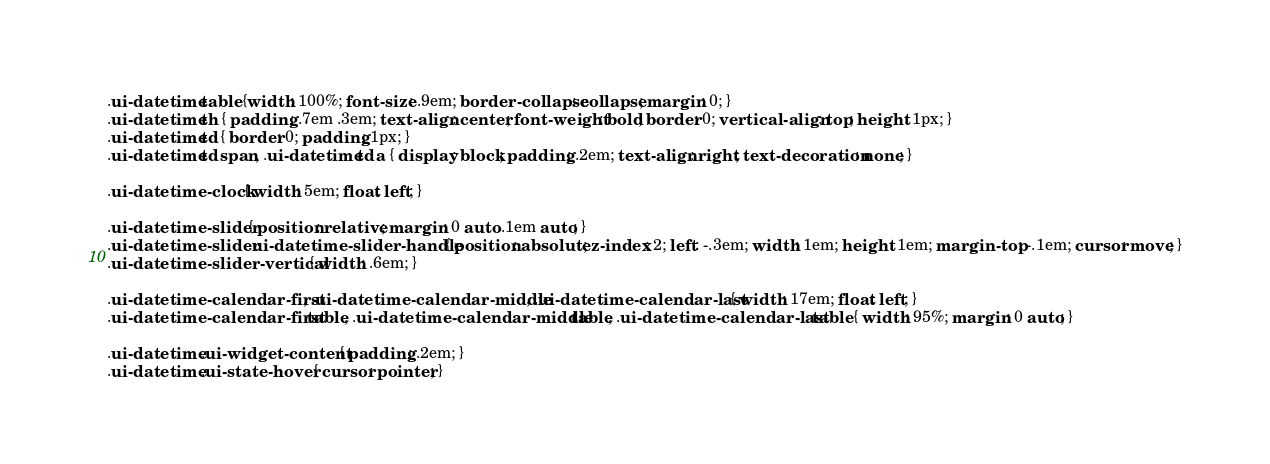Convert code to text. <code><loc_0><loc_0><loc_500><loc_500><_CSS_>
.ui-datetime table {width: 100%; font-size: .9em; border-collapse: collapse; margin: 0; }
.ui-datetime th { padding: .7em .3em; text-align: center; font-weight: bold; border: 0; vertical-align: top; height: 1px; }
.ui-datetime td { border: 0; padding: 1px; }
.ui-datetime td span, .ui-datetime td a { display: block; padding: .2em; text-align: right; text-decoration: none; }

.ui-datetime-clock { width: 5em; float: left; }

.ui-datetime-slider { position: relative; margin: 0 auto .1em auto; }
.ui-datetime-slider .ui-datetime-slider-handle { position: absolute; z-index: 2; left: -.3em; width: 1em; height: 1em; margin-top: -.1em; cursor: move; }
.ui-datetime-slider-vertical { width: .6em; }

.ui-datetime-calendar-first, .ui-datetime-calendar-middle, .ui-datetime-calendar-last { width: 17em; float: left; }
.ui-datetime-calendar-first table, .ui-datetime-calendar-middle table, .ui-datetime-calendar-last table { width: 95%; margin: 0 auto; }

.ui-datetime .ui-widget-content { padding: .2em; }
.ui-datetime .ui-state-hover { cursor: pointer; }</code> 